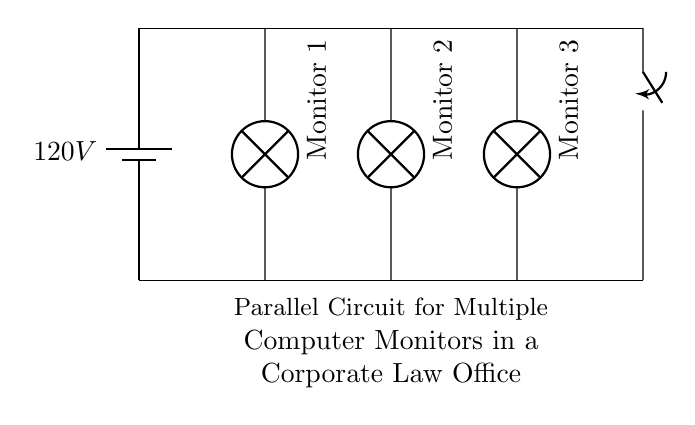What is the voltage in the circuit? The voltage in the circuit is labeled as 120V, which is the voltage supplied by the battery shown in the diagram.
Answer: 120V How many monitors are connected in this parallel circuit? The circuit diagram shows three monitors connected in parallel, each represented by a lamp symbol.
Answer: Three What type of circuit is shown in the diagram? The circuit is a parallel circuit, as indicated by the arrangement of the components where each device has its own direct connection to the power source.
Answer: Parallel What is the role of the switch in this circuit? The switch in the circuit functions to control the overall power supply to the monitors, allowing the user to turn all monitors on or off simultaneously.
Answer: Control If one monitor fails, what happens to the others? In a parallel circuit, if one monitor were to fail or be disconnected, the remaining monitors would still continue to operate normally because each has its own separate path to the power source.
Answer: They remain operational What is the current across each monitor based on the circuit type? In a parallel circuit, the current can vary across each device depending on its resistance, but each monitor shares the same voltage of 120V across it.
Answer: Varies by resistance 